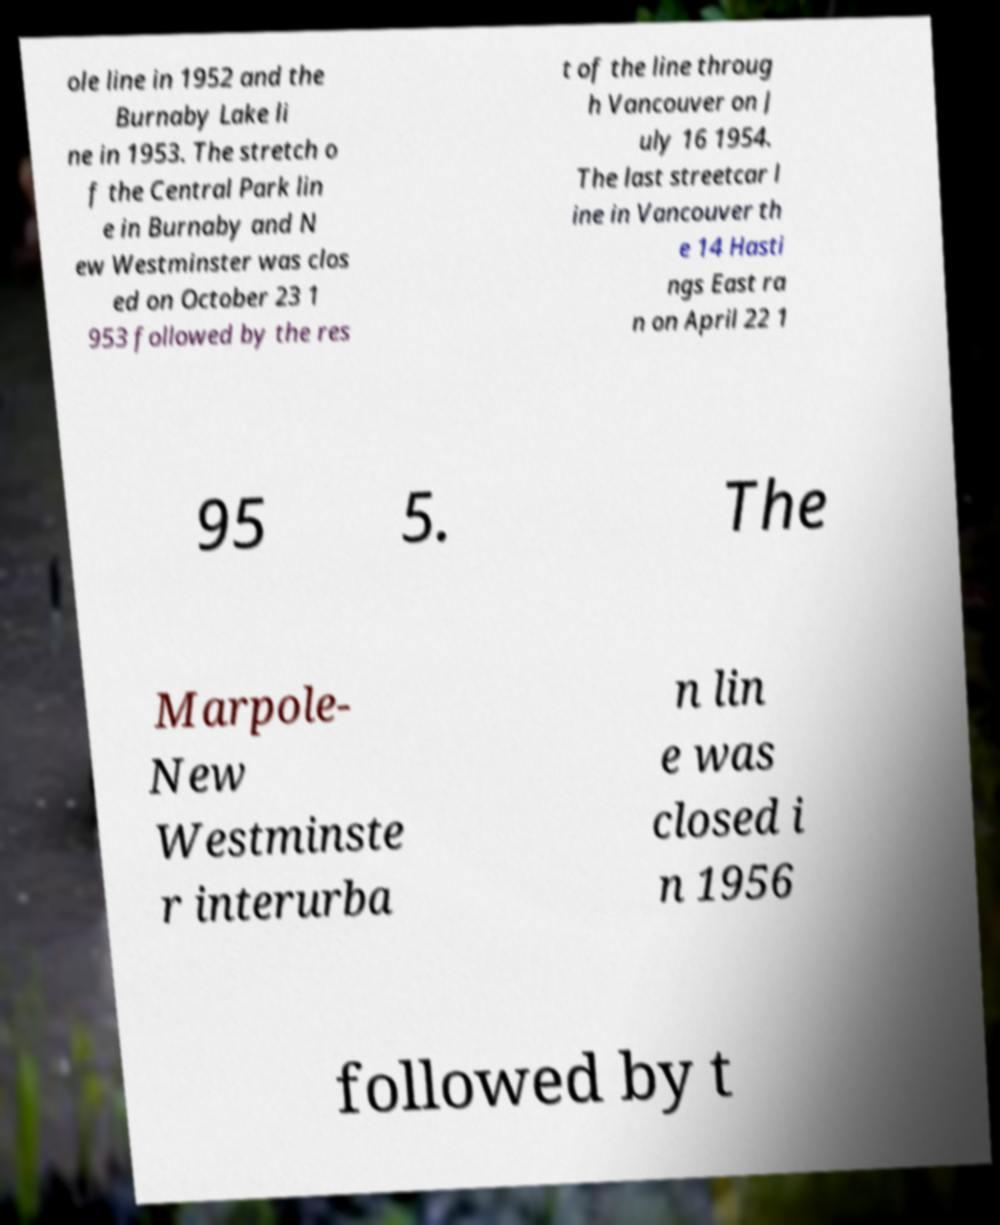Can you read and provide the text displayed in the image?This photo seems to have some interesting text. Can you extract and type it out for me? ole line in 1952 and the Burnaby Lake li ne in 1953. The stretch o f the Central Park lin e in Burnaby and N ew Westminster was clos ed on October 23 1 953 followed by the res t of the line throug h Vancouver on J uly 16 1954. The last streetcar l ine in Vancouver th e 14 Hasti ngs East ra n on April 22 1 95 5. The Marpole- New Westminste r interurba n lin e was closed i n 1956 followed by t 